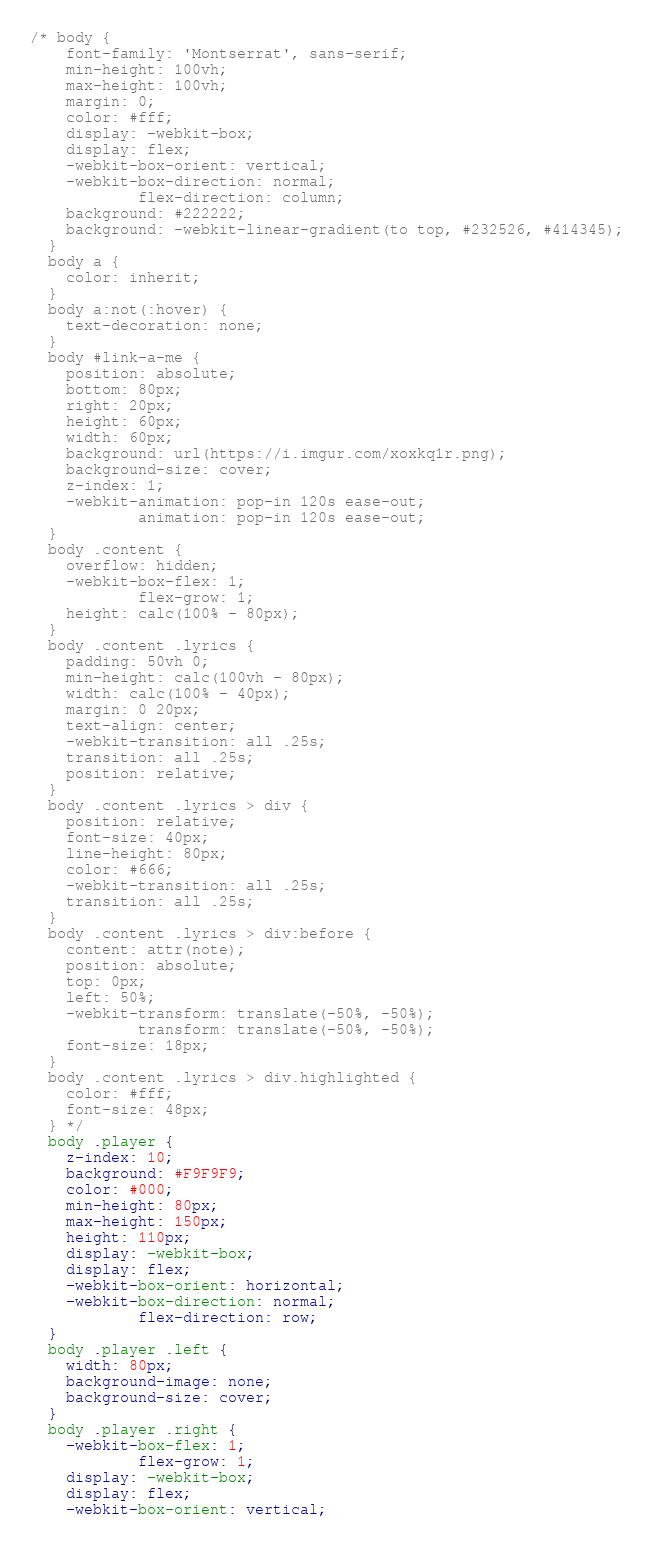Convert code to text. <code><loc_0><loc_0><loc_500><loc_500><_CSS_>/* body {
    font-family: 'Montserrat', sans-serif;
    min-height: 100vh;
    max-height: 100vh;
    margin: 0;
    color: #fff;
    display: -webkit-box;
    display: flex;
    -webkit-box-orient: vertical;
    -webkit-box-direction: normal;
            flex-direction: column;
    background: #222222;
    background: -webkit-linear-gradient(to top, #232526, #414345);
  }
  body a {
    color: inherit;
  }
  body a:not(:hover) {
    text-decoration: none;
  }
  body #link-a-me {
    position: absolute;
    bottom: 80px;
    right: 20px;
    height: 60px;
    width: 60px;
    background: url(https://i.imgur.com/xoxkq1r.png);
    background-size: cover;
    z-index: 1;
    -webkit-animation: pop-in 120s ease-out;
            animation: pop-in 120s ease-out;
  }
  body .content {
    overflow: hidden;
    -webkit-box-flex: 1;
            flex-grow: 1;
    height: calc(100% - 80px);
  }
  body .content .lyrics {
    padding: 50vh 0;
    min-height: calc(100vh - 80px);
    width: calc(100% - 40px);
    margin: 0 20px;
    text-align: center;
    -webkit-transition: all .25s;
    transition: all .25s;
    position: relative;
  }
  body .content .lyrics > div {
    position: relative;
    font-size: 40px;
    line-height: 80px;
    color: #666;
    -webkit-transition: all .25s;
    transition: all .25s;
  }
  body .content .lyrics > div:before {
    content: attr(note);
    position: absolute;
    top: 0px;
    left: 50%;
    -webkit-transform: translate(-50%, -50%);
            transform: translate(-50%, -50%);
    font-size: 18px;
  }
  body .content .lyrics > div.highlighted {
    color: #fff;
    font-size: 48px;
  } */
  body .player {
    z-index: 10;
    background: #F9F9F9;
    color: #000;
    min-height: 80px;
    max-height: 150px;
    height: 110px;
    display: -webkit-box;
    display: flex;
    -webkit-box-orient: horizontal;
    -webkit-box-direction: normal;
            flex-direction: row;
  }
  body .player .left {
    width: 80px;
    background-image: none;
    background-size: cover;
  }
  body .player .right {
    -webkit-box-flex: 1;
            flex-grow: 1;
    display: -webkit-box;
    display: flex;
    -webkit-box-orient: vertical;</code> 